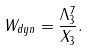Convert formula to latex. <formula><loc_0><loc_0><loc_500><loc_500>W _ { d y n } = \frac { \Lambda _ { 3 } ^ { 7 } } { X _ { 3 } } .</formula> 